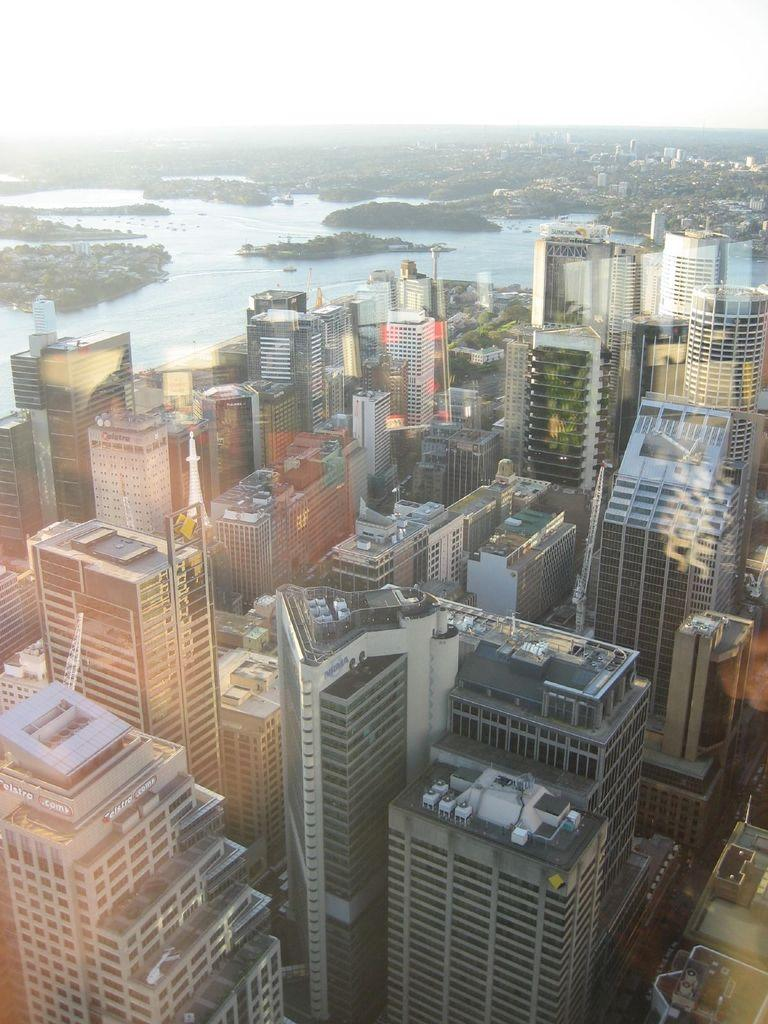What type of structures are located in the front of the image? There are buildings in the front of the image. What natural element can be seen in the background of the image? There is water visible in the background of the image. What is visible at the top of the image? The sky is visible at the top of the image. Where is the notebook placed in the image? There is no notebook present in the image. What type of cap is worn by the coach in the image? There is no coach or cap present in the image. 